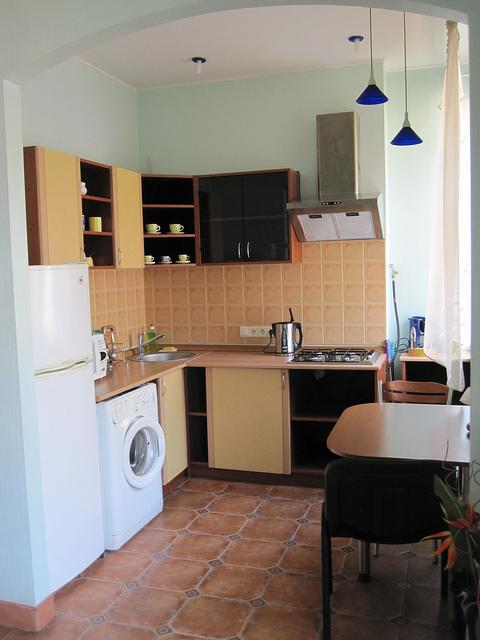Which appliance sits right next to the refrigerator? washer 